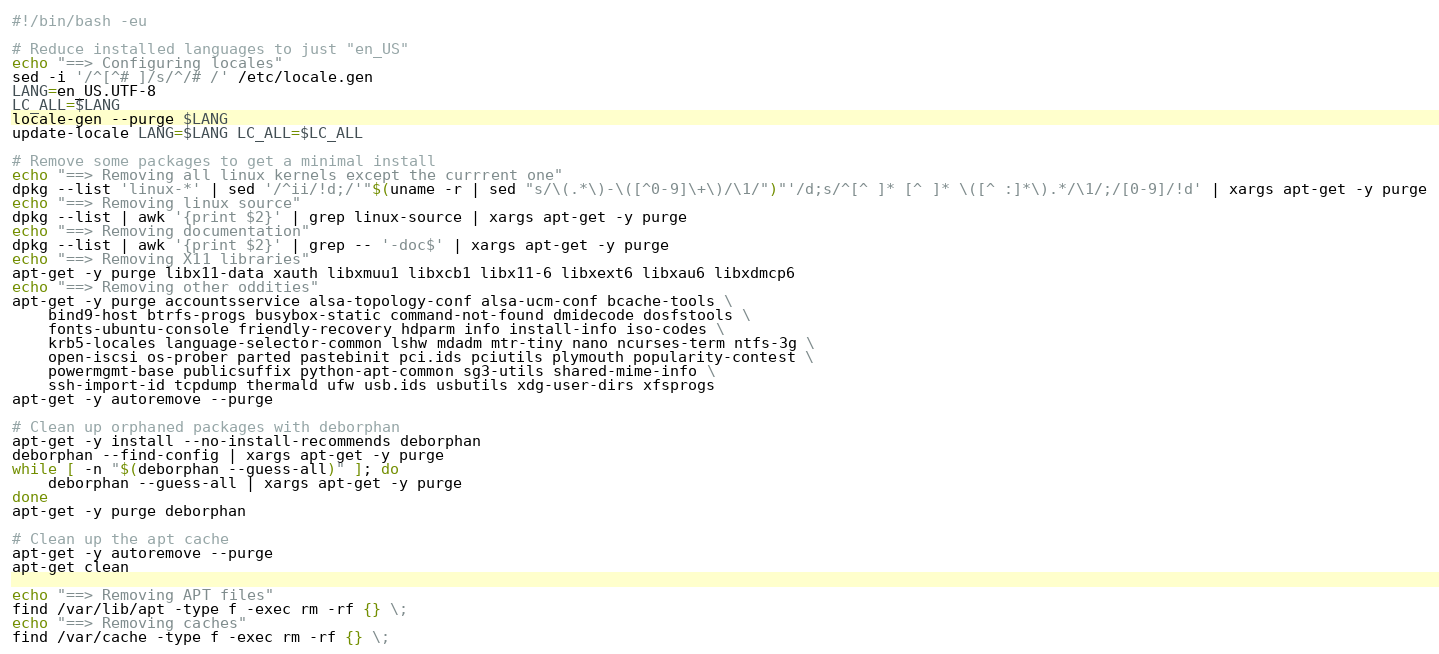Convert code to text. <code><loc_0><loc_0><loc_500><loc_500><_Bash_>#!/bin/bash -eu

# Reduce installed languages to just "en_US"
echo "==> Configuring locales"
sed -i '/^[^# ]/s/^/# /' /etc/locale.gen
LANG=en_US.UTF-8
LC_ALL=$LANG
locale-gen --purge $LANG
update-locale LANG=$LANG LC_ALL=$LC_ALL

# Remove some packages to get a minimal install
echo "==> Removing all linux kernels except the currrent one"
dpkg --list 'linux-*' | sed '/^ii/!d;/'"$(uname -r | sed "s/\(.*\)-\([^0-9]\+\)/\1/")"'/d;s/^[^ ]* [^ ]* \([^ :]*\).*/\1/;/[0-9]/!d' | xargs apt-get -y purge
echo "==> Removing linux source"
dpkg --list | awk '{print $2}' | grep linux-source | xargs apt-get -y purge
echo "==> Removing documentation"
dpkg --list | awk '{print $2}' | grep -- '-doc$' | xargs apt-get -y purge
echo "==> Removing X11 libraries"
apt-get -y purge libx11-data xauth libxmuu1 libxcb1 libx11-6 libxext6 libxau6 libxdmcp6
echo "==> Removing other oddities"
apt-get -y purge accountsservice alsa-topology-conf alsa-ucm-conf bcache-tools \
    bind9-host btrfs-progs busybox-static command-not-found dmidecode dosfstools \
    fonts-ubuntu-console friendly-recovery hdparm info install-info iso-codes \
    krb5-locales language-selector-common lshw mdadm mtr-tiny nano ncurses-term ntfs-3g \
    open-iscsi os-prober parted pastebinit pci.ids pciutils plymouth popularity-contest \
    powermgmt-base publicsuffix python-apt-common sg3-utils shared-mime-info \
    ssh-import-id tcpdump thermald ufw usb.ids usbutils xdg-user-dirs xfsprogs
apt-get -y autoremove --purge

# Clean up orphaned packages with deborphan
apt-get -y install --no-install-recommends deborphan
deborphan --find-config | xargs apt-get -y purge
while [ -n "$(deborphan --guess-all)" ]; do
    deborphan --guess-all | xargs apt-get -y purge
done
apt-get -y purge deborphan

# Clean up the apt cache
apt-get -y autoremove --purge
apt-get clean

echo "==> Removing APT files"
find /var/lib/apt -type f -exec rm -rf {} \;
echo "==> Removing caches"
find /var/cache -type f -exec rm -rf {} \;
</code> 